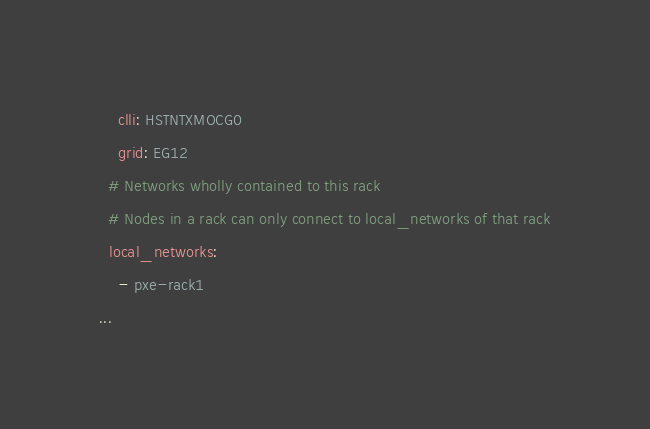<code> <loc_0><loc_0><loc_500><loc_500><_YAML_>    clli: HSTNTXMOCG0
    grid: EG12
  # Networks wholly contained to this rack
  # Nodes in a rack can only connect to local_networks of that rack
  local_networks:
    - pxe-rack1
...</code> 